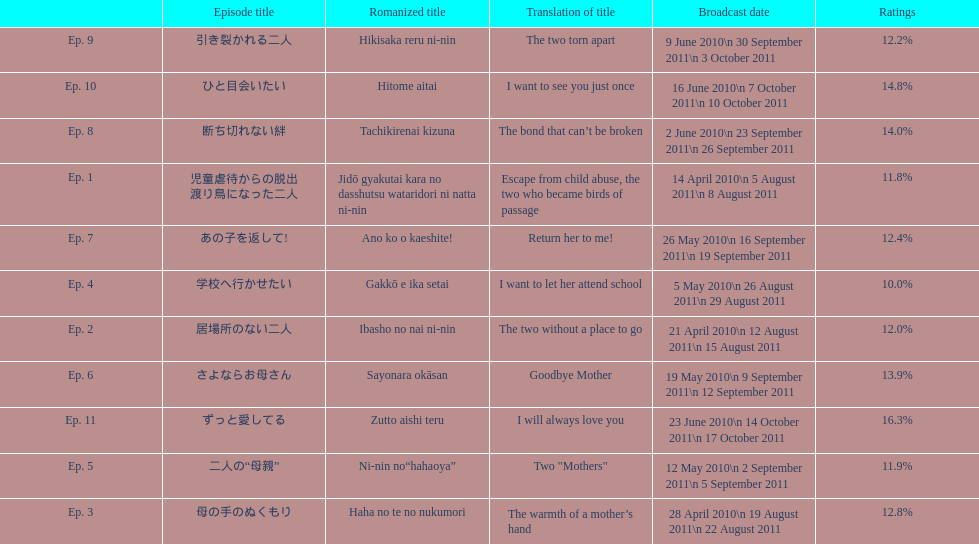In april 2010, how many episodes were shown in japan? 3. 